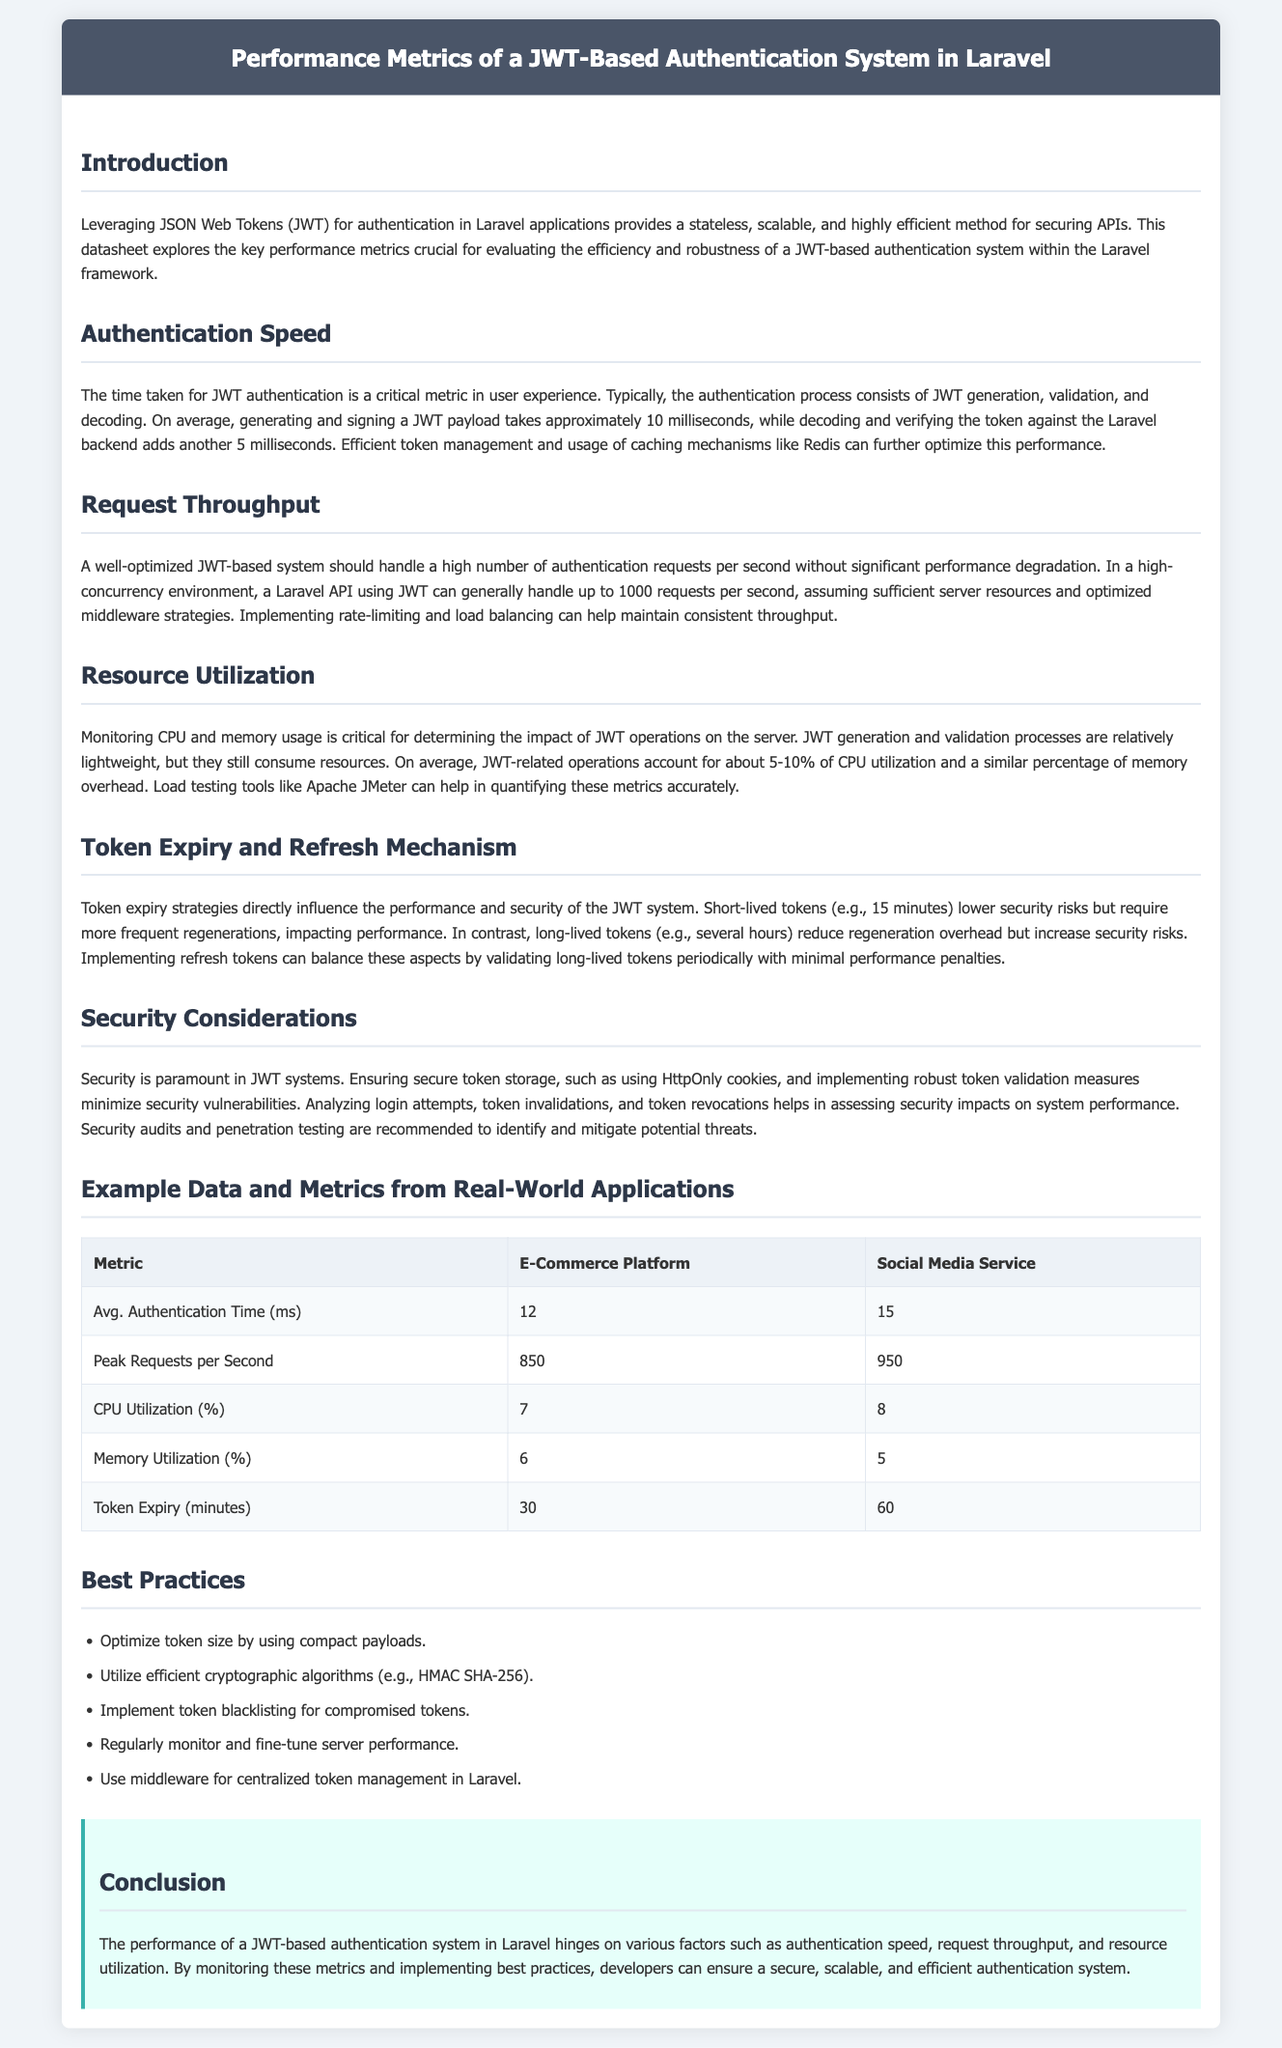What is the average time for JWT authentication? The average time for JWT authentication includes the time taken for generation, validation, and decoding, which is approximately 15 milliseconds.
Answer: 15 milliseconds What is the peak requests per second for the E-Commerce platform? The peak requests per second metric for the E-Commerce platform indicates the maximum load it can handle, which is 850.
Answer: 850 What percentage of CPU utilization do JWT-related operations account for? The data on resource utilization mentions that JWT-related operations account for about 5-10% of CPU utilization.
Answer: 5-10% What is the token expiry time in minutes for the Social Media Service? The token expiry time for the Social Media Service is specified in the document, which is 60 minutes.
Answer: 60 minutes What are the two JWT generation and validation times combined? The JWT generation time is 10 milliseconds and the validation time is 5 milliseconds, together they sum to 15 milliseconds.
Answer: 15 milliseconds Are short-lived tokens mentioned as having higher or lower security risks? The document states that short-lived tokens lower security risks but require more frequent regenerations, which could impact performance.
Answer: Lower What cryptographic algorithm is recommended for JWT? The datasheet suggests utilizing efficient cryptographic algorithms, specifically mentioning HMAC SHA-256.
Answer: HMAC SHA-256 What tool can help quantify CPU and memory usage metrics accurately? The document mentions using Apache JMeter to help in quantifying CPU and memory usage metrics accurately.
Answer: Apache JMeter What is one of the best practices for managing tokens in Laravel? The document lists several best practices, one being to use middleware for centralized token management in Laravel.
Answer: Middleware 